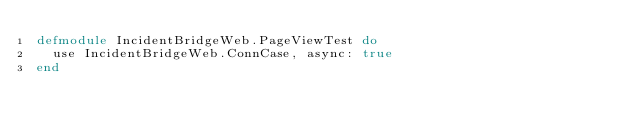<code> <loc_0><loc_0><loc_500><loc_500><_Elixir_>defmodule IncidentBridgeWeb.PageViewTest do
  use IncidentBridgeWeb.ConnCase, async: true
end
</code> 